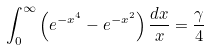<formula> <loc_0><loc_0><loc_500><loc_500>\int _ { 0 } ^ { \infty } \left ( e ^ { - x ^ { 4 } } - e ^ { - x ^ { 2 } } \right ) \frac { d x } { x } = \frac { \gamma } { 4 }</formula> 